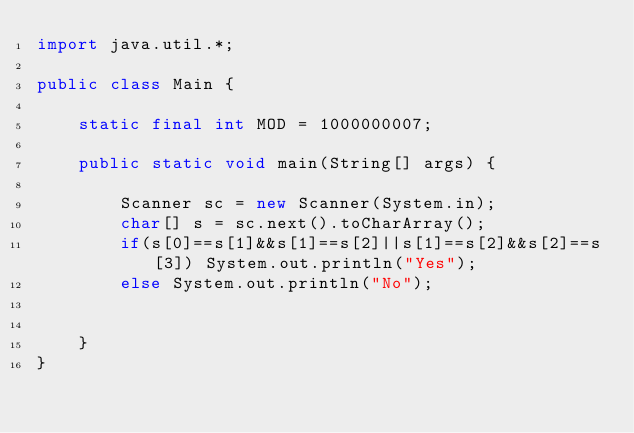<code> <loc_0><loc_0><loc_500><loc_500><_Java_>import java.util.*;

public class Main {

    static final int MOD = 1000000007;

    public static void main(String[] args) {

        Scanner sc = new Scanner(System.in);
        char[] s = sc.next().toCharArray();
        if(s[0]==s[1]&&s[1]==s[2]||s[1]==s[2]&&s[2]==s[3]) System.out.println("Yes");
        else System.out.println("No");


    }
}
</code> 